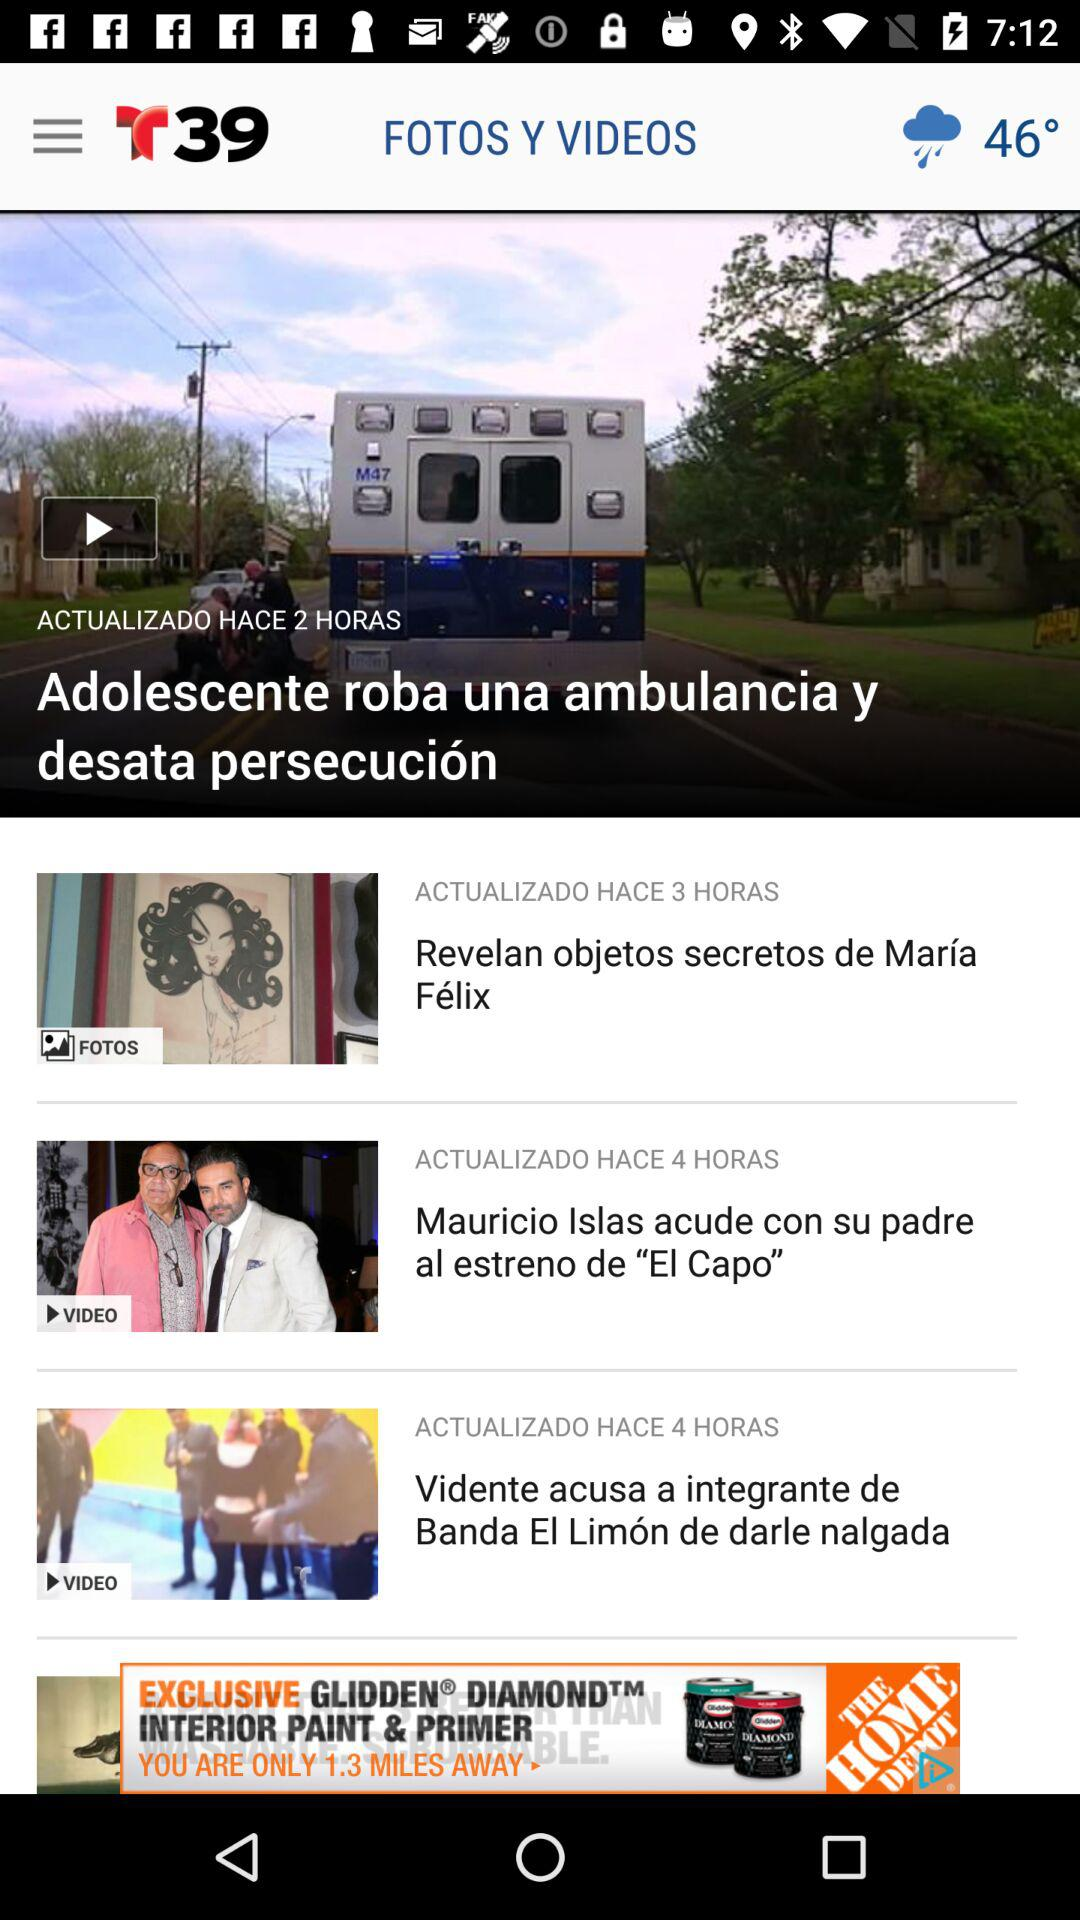What is the temperature? The temperature is 46°. 